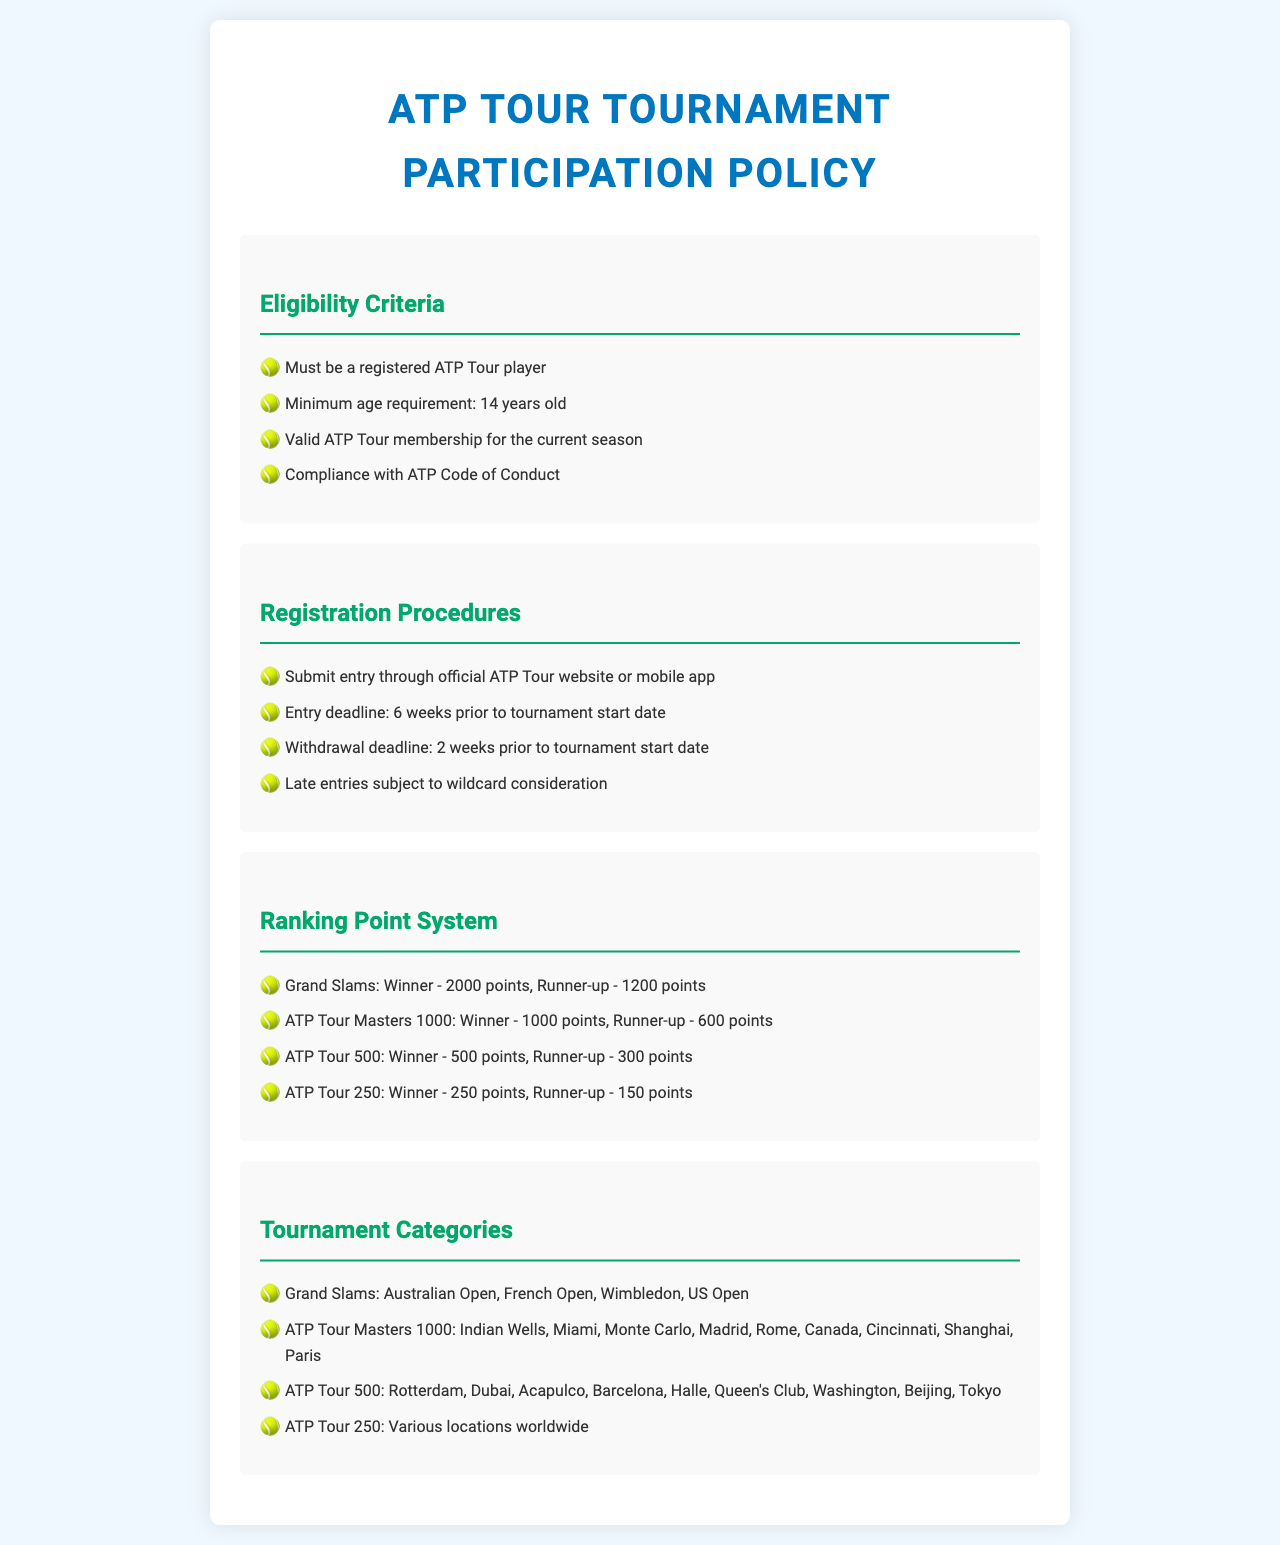What is the minimum age requirement to participate? According to the eligibility criteria in the document, participants must be at least 14 years old.
Answer: 14 years old What is the deadline for withdrawal from a tournament? The document states that the withdrawal deadline is two weeks prior to the tournament start date.
Answer: 2 weeks How many points does a Grand Slam winner receive? The ranking point system specifies that a Grand Slam winner receives 2000 points.
Answer: 2000 points Which tournaments are classified as ATP Tour 500? The document lists specific tournaments that fall under ATP Tour 500, such as Rotterdam, Dubai, and Acapulco.
Answer: Rotterdam, Dubai, Acapulco What is required for ATP Tour membership? The eligibility criteria state that players must have a valid ATP Tour membership for the current season.
Answer: Valid ATP Tour membership What are the late entries subject to? The registration procedure notes that late entries may be subject to wildcard consideration.
Answer: Wildcard consideration How many points does an ATP Tour 250 runner-up receive? The ranking point system indicates that the runner-up in an ATP Tour 250 event receives 150 points.
Answer: 150 points Name one Grand Slam tournament. The document specifies that Grand Slam tournaments include the Australian Open, among others.
Answer: Australian Open What must players comply with according to the eligibility criteria? Players are required to comply with the ATP Code of Conduct according to the document.
Answer: ATP Code of Conduct 